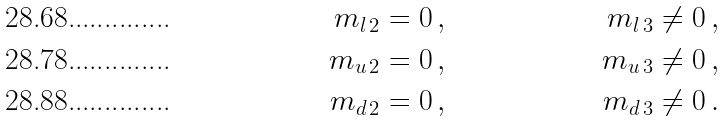<formula> <loc_0><loc_0><loc_500><loc_500>m _ { l \, 2 } & = 0 \, , & m _ { l \, 3 } & \neq 0 \, , \\ m _ { u \, 2 } & = 0 \, , & m _ { u \, 3 } & \neq 0 \, , \\ m _ { d \, 2 } & = 0 \, , & m _ { d \, 3 } & \neq 0 \, .</formula> 